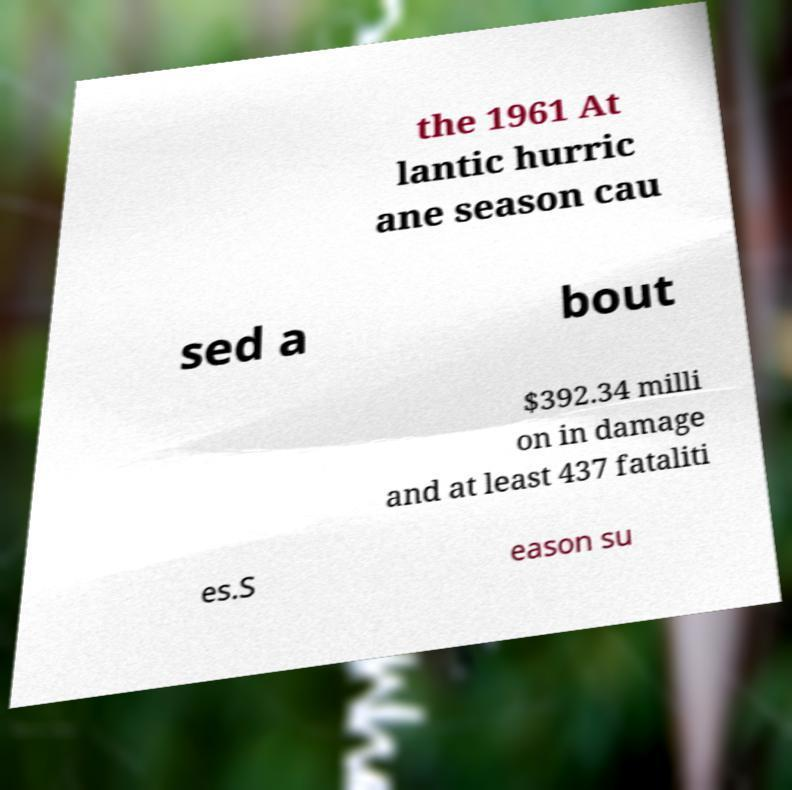I need the written content from this picture converted into text. Can you do that? the 1961 At lantic hurric ane season cau sed a bout $392.34 milli on in damage and at least 437 fataliti es.S eason su 